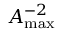Convert formula to latex. <formula><loc_0><loc_0><loc_500><loc_500>{ A _ { \max } } ^ { - 2 }</formula> 